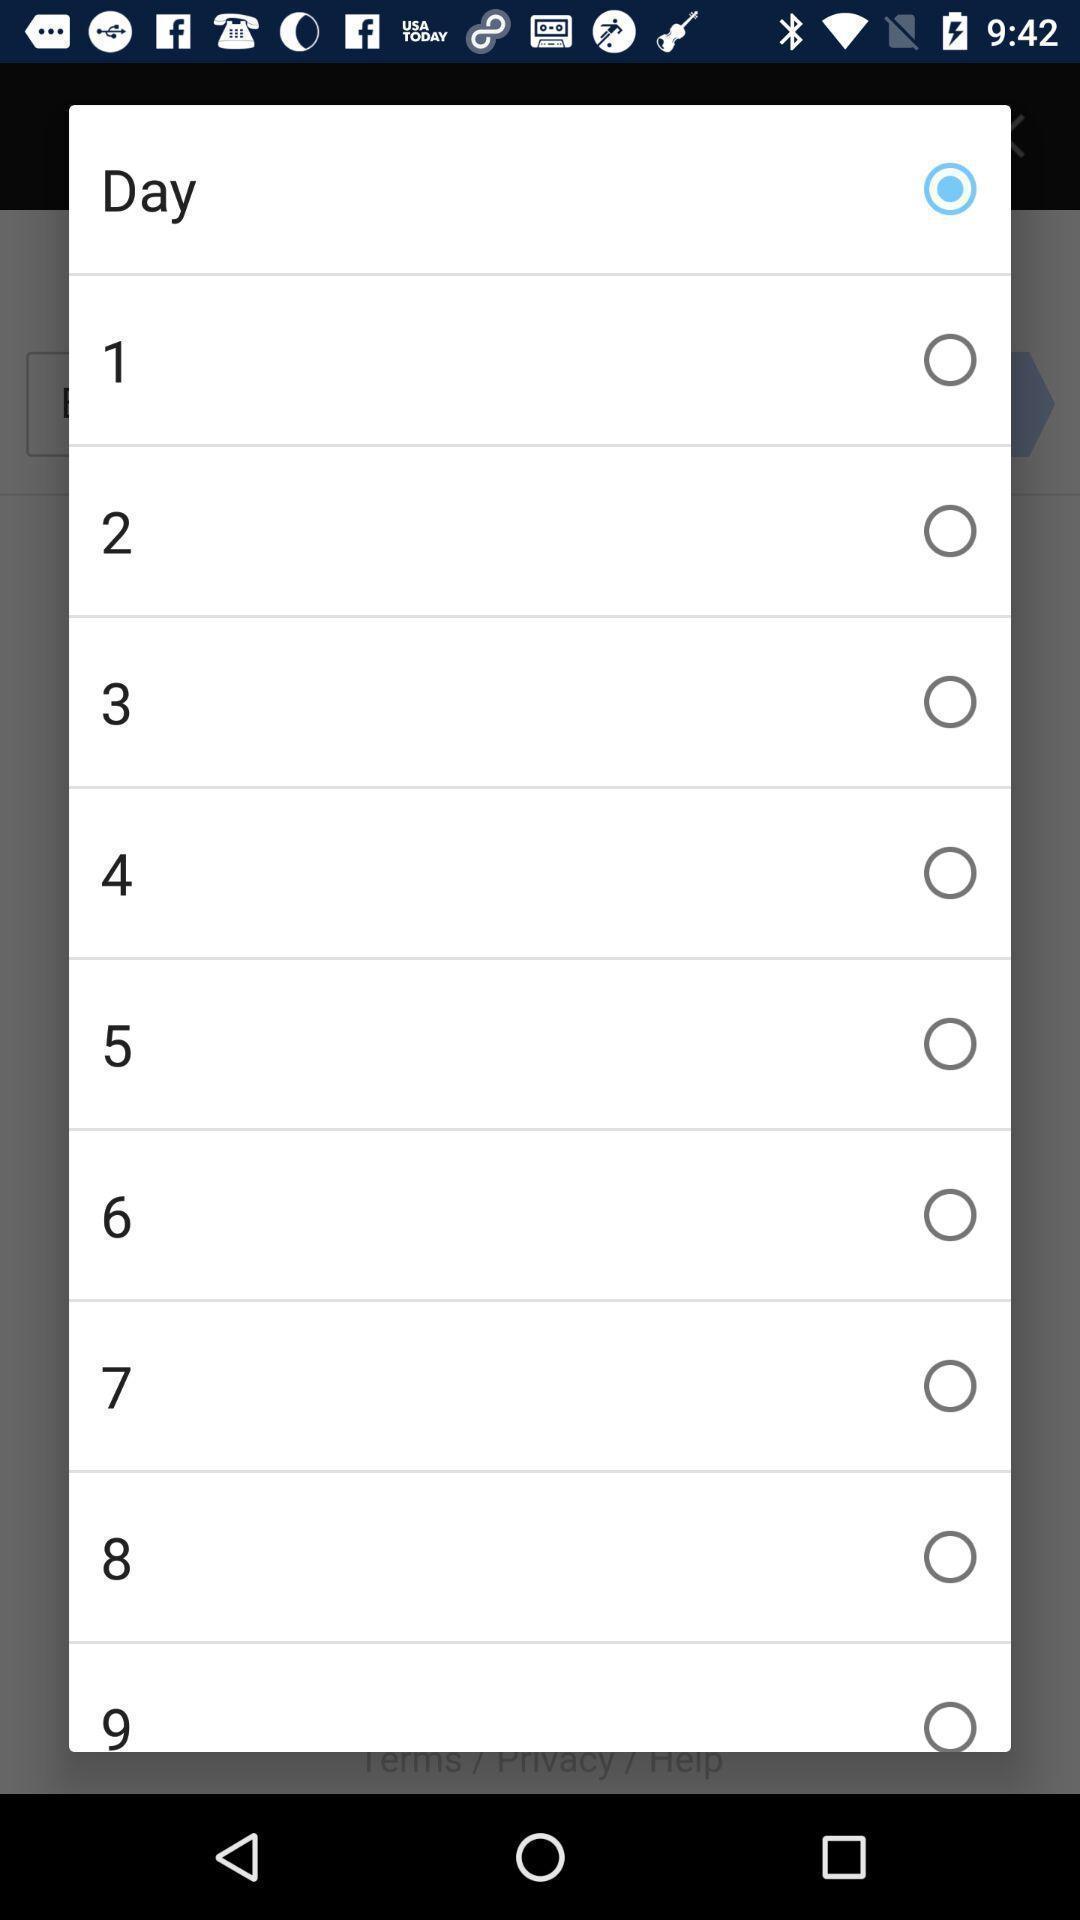What details can you identify in this image? Pop-up with selection options in a messaging app. 